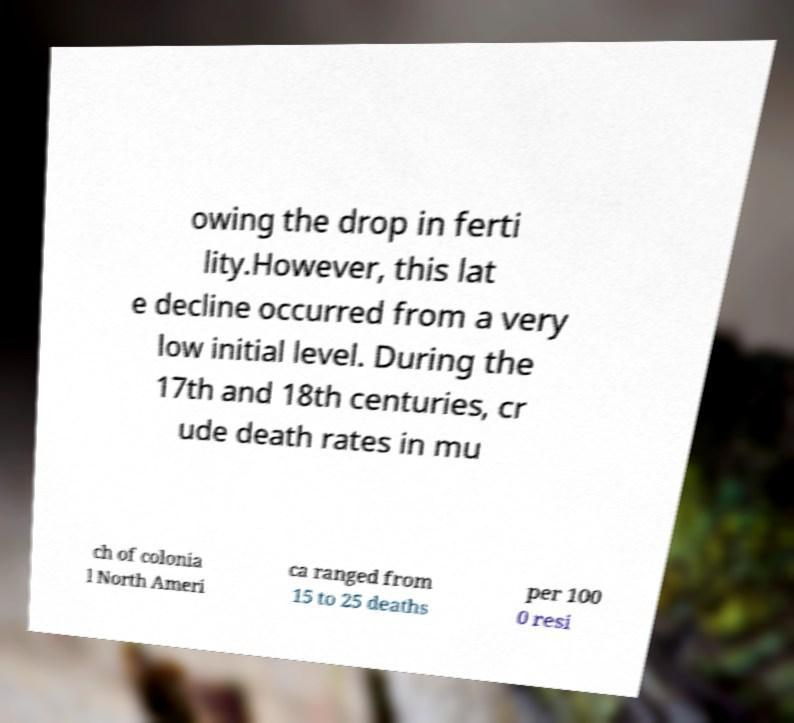Could you assist in decoding the text presented in this image and type it out clearly? owing the drop in ferti lity.However, this lat e decline occurred from a very low initial level. During the 17th and 18th centuries, cr ude death rates in mu ch of colonia l North Ameri ca ranged from 15 to 25 deaths per 100 0 resi 